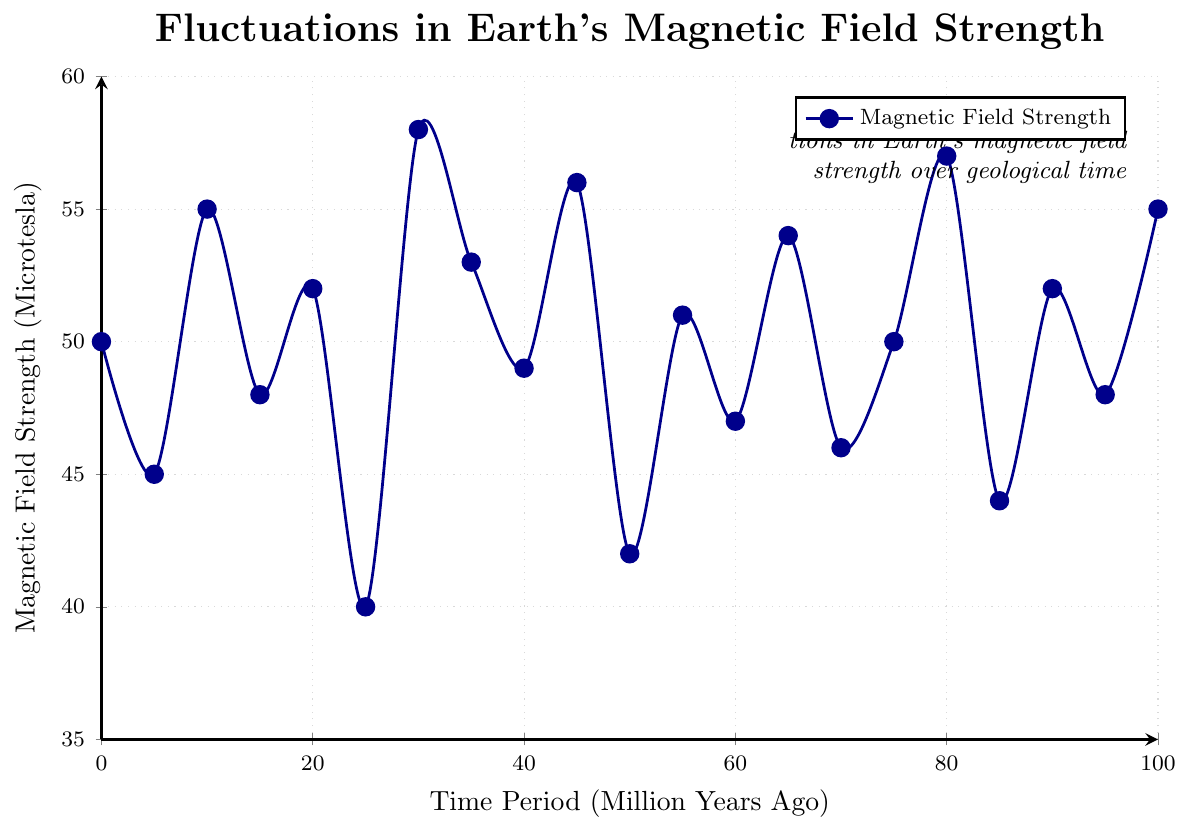What is the range of magnetic field strength values depicted in the figure? To determine the range, identify the minimum and maximum magnetic field strengths. The minimum value is 40 microteslas (at 25 million years ago), and the maximum value is 58 microteslas (at 30 million years ago). Therefore, the range is 58 - 40.
Answer: 18 microteslas Is the magnetic field strength at 10 million years ago higher or lower than at 15 million years ago? From the figure, observe the magnetic field strengths at 10 million years ago (55 microteslas) and 15 million years ago (48 microteslas). Compare the two values. 55 microteslas is higher than 48 microteslas.
Answer: Higher What is the difference in magnetic field strength between the present and 65 million years ago? From the figure, the magnetic field strength at the present is 50 microteslas, and at 65 million years ago, it is 54 microteslas. To find the difference, subtract 50 from 54.
Answer: 4 microteslas Considering the time periods of 45 million years ago and 50 million years ago, which one has a higher magnetic field strength? By checking the values on the figure, 45 million years ago has a magnetic field strength of 56 microteslas, and 50 million years ago has 42 microteslas. Comparing these, 56 is higher than 42.
Answer: 45 million years ago What are the average magnetic field strengths at the intervals of 0, 25, 50, and 75 million years ago? Locate the magnetic field strengths at 0 (50), 25 (40), 50 (42), and 75 (50) million years ago. Sum these values and divide by the number of values: (50 + 40 + 42 + 50) / 4.
Answer: 45.5 microteslas How does the magnetic field strength at the peak value (58 microteslas) compare to the mean magnetic field strength over the entire described period? First, identify the peak value, which is 58 microteslas. Then, calculate the mean magnetic field strength by adding all values and dividing by the number of data points (21). Adding all values provided gives a sum of 1048. Dividing by 21 results in an average of 49.9. Compare this mean with the peak value.
Answer: The peak value (58) is higher than the mean (49.9) At which time period did the magnetic field strength drop to its lowest point, and what was this value? By locating the lowest value in the figure, it is observed at 25 million years ago with a value of 40 microteslas.
Answer: 25 million years ago, 40 microteslas Is there any noticeable cyclical pattern in the fluctuations of the Earth's magnetic field as shown in the figure? Review the plot for repeating patterns or cycles in the rising and falling trends of the magnetic field strength. Identify visible repeating peaks and valleys. The annotation in the figure itself also mentions cyclical variations.
Answer: Yes, there is a noticeable cyclical pattern 